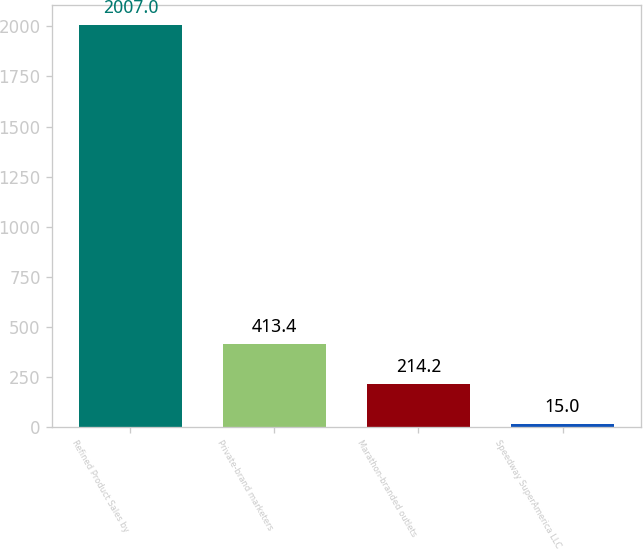Convert chart. <chart><loc_0><loc_0><loc_500><loc_500><bar_chart><fcel>Refined Product Sales by<fcel>Private-brand marketers<fcel>Marathon-branded outlets<fcel>Speedway SuperAmerica LLC<nl><fcel>2007<fcel>413.4<fcel>214.2<fcel>15<nl></chart> 